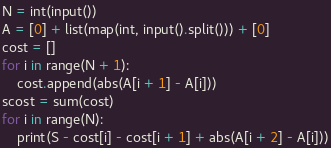Convert code to text. <code><loc_0><loc_0><loc_500><loc_500><_Python_>N = int(input())
A = [0] + list(map(int, input().split())) + [0]
cost = []
for i in range(N + 1):
    cost.append(abs(A[i + 1] - A[i]))
scost = sum(cost)
for i in range(N):
    print(S - cost[i] - cost[i + 1] + abs(A[i + 2] - A[i]))
</code> 